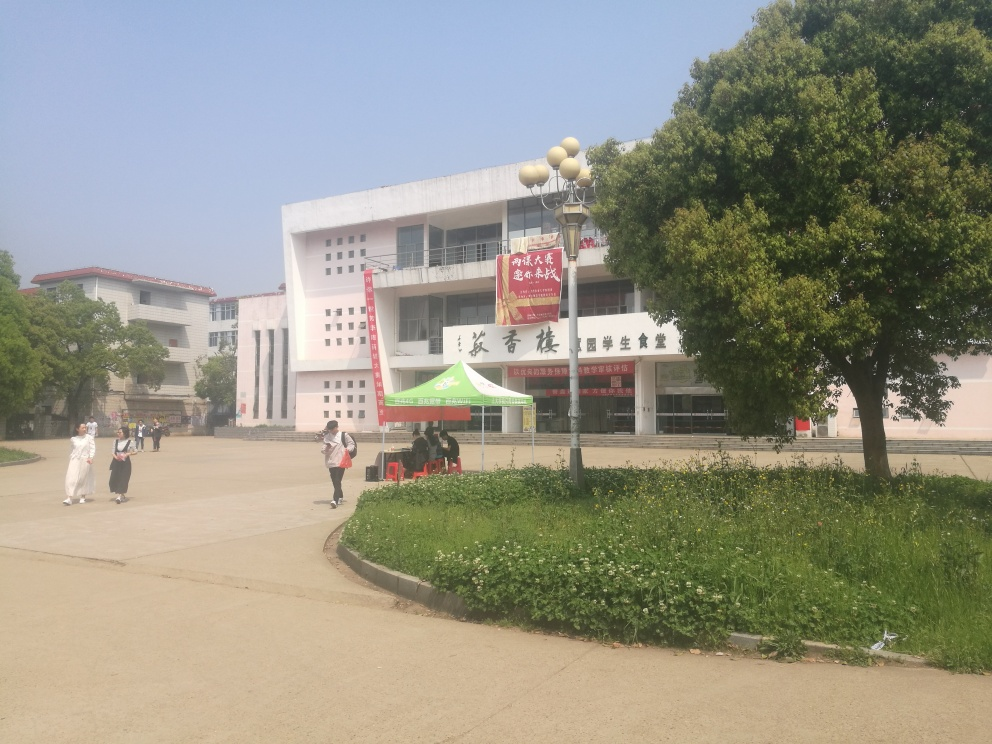How is the background in the image?
A. Cluttered background
B. Relatively clear
C. Distracting background
Answer with the option's letter from the given choices directly. The background of the image can be described as relatively clear, which corresponds to option B. The space is open and there are no excessive elements that draw the eye away from the central building and the surrounding greenery, which together create a pleasant and focused scene. 